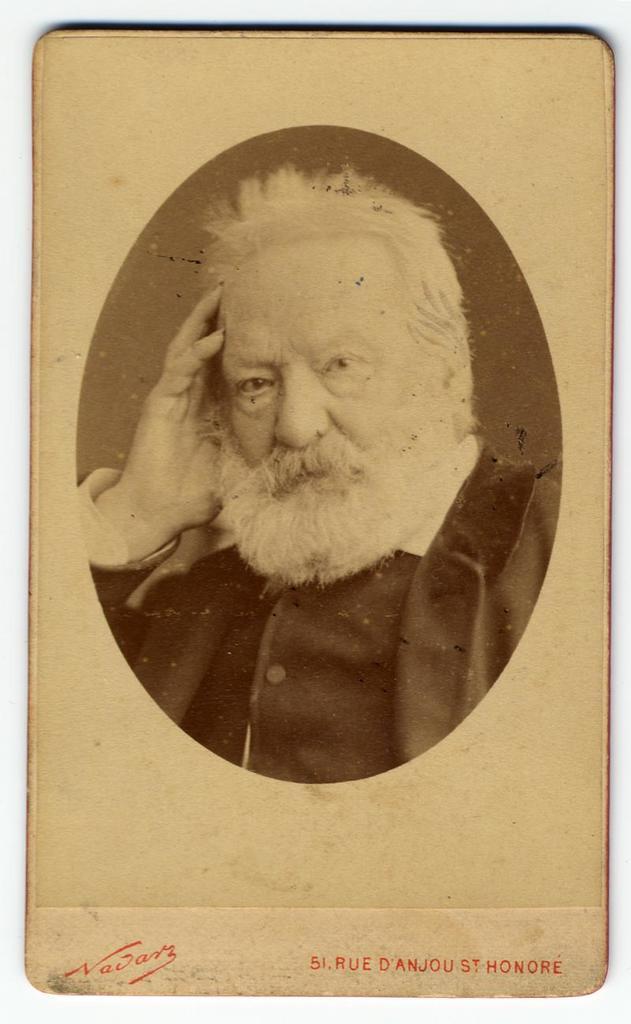How would you summarize this image in a sentence or two? In the image there is a picture of a man and under the picture there is some text. 